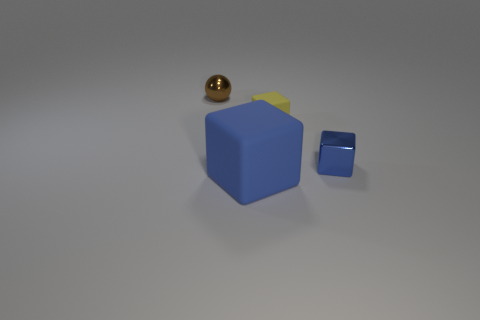The other tiny object that is the same shape as the tiny yellow rubber thing is what color?
Provide a succinct answer. Blue. There is a shiny thing that is left of the blue rubber object; does it have the same color as the tiny matte object?
Make the answer very short. No. Is there a tiny matte block of the same color as the tiny metallic ball?
Ensure brevity in your answer.  No. What number of cubes are in front of the tiny matte block?
Make the answer very short. 2. How many other things are the same size as the blue rubber cube?
Offer a very short reply. 0. Is the yellow thing that is right of the large rubber block made of the same material as the tiny object in front of the yellow block?
Give a very brief answer. No. There is a ball that is the same size as the yellow rubber cube; what is its color?
Provide a short and direct response. Brown. Is there any other thing of the same color as the metal ball?
Provide a succinct answer. No. What is the size of the matte object behind the thing in front of the metallic object in front of the brown metallic thing?
Make the answer very short. Small. What color is the thing that is on the left side of the tiny rubber thing and in front of the small yellow object?
Your response must be concise. Blue. 